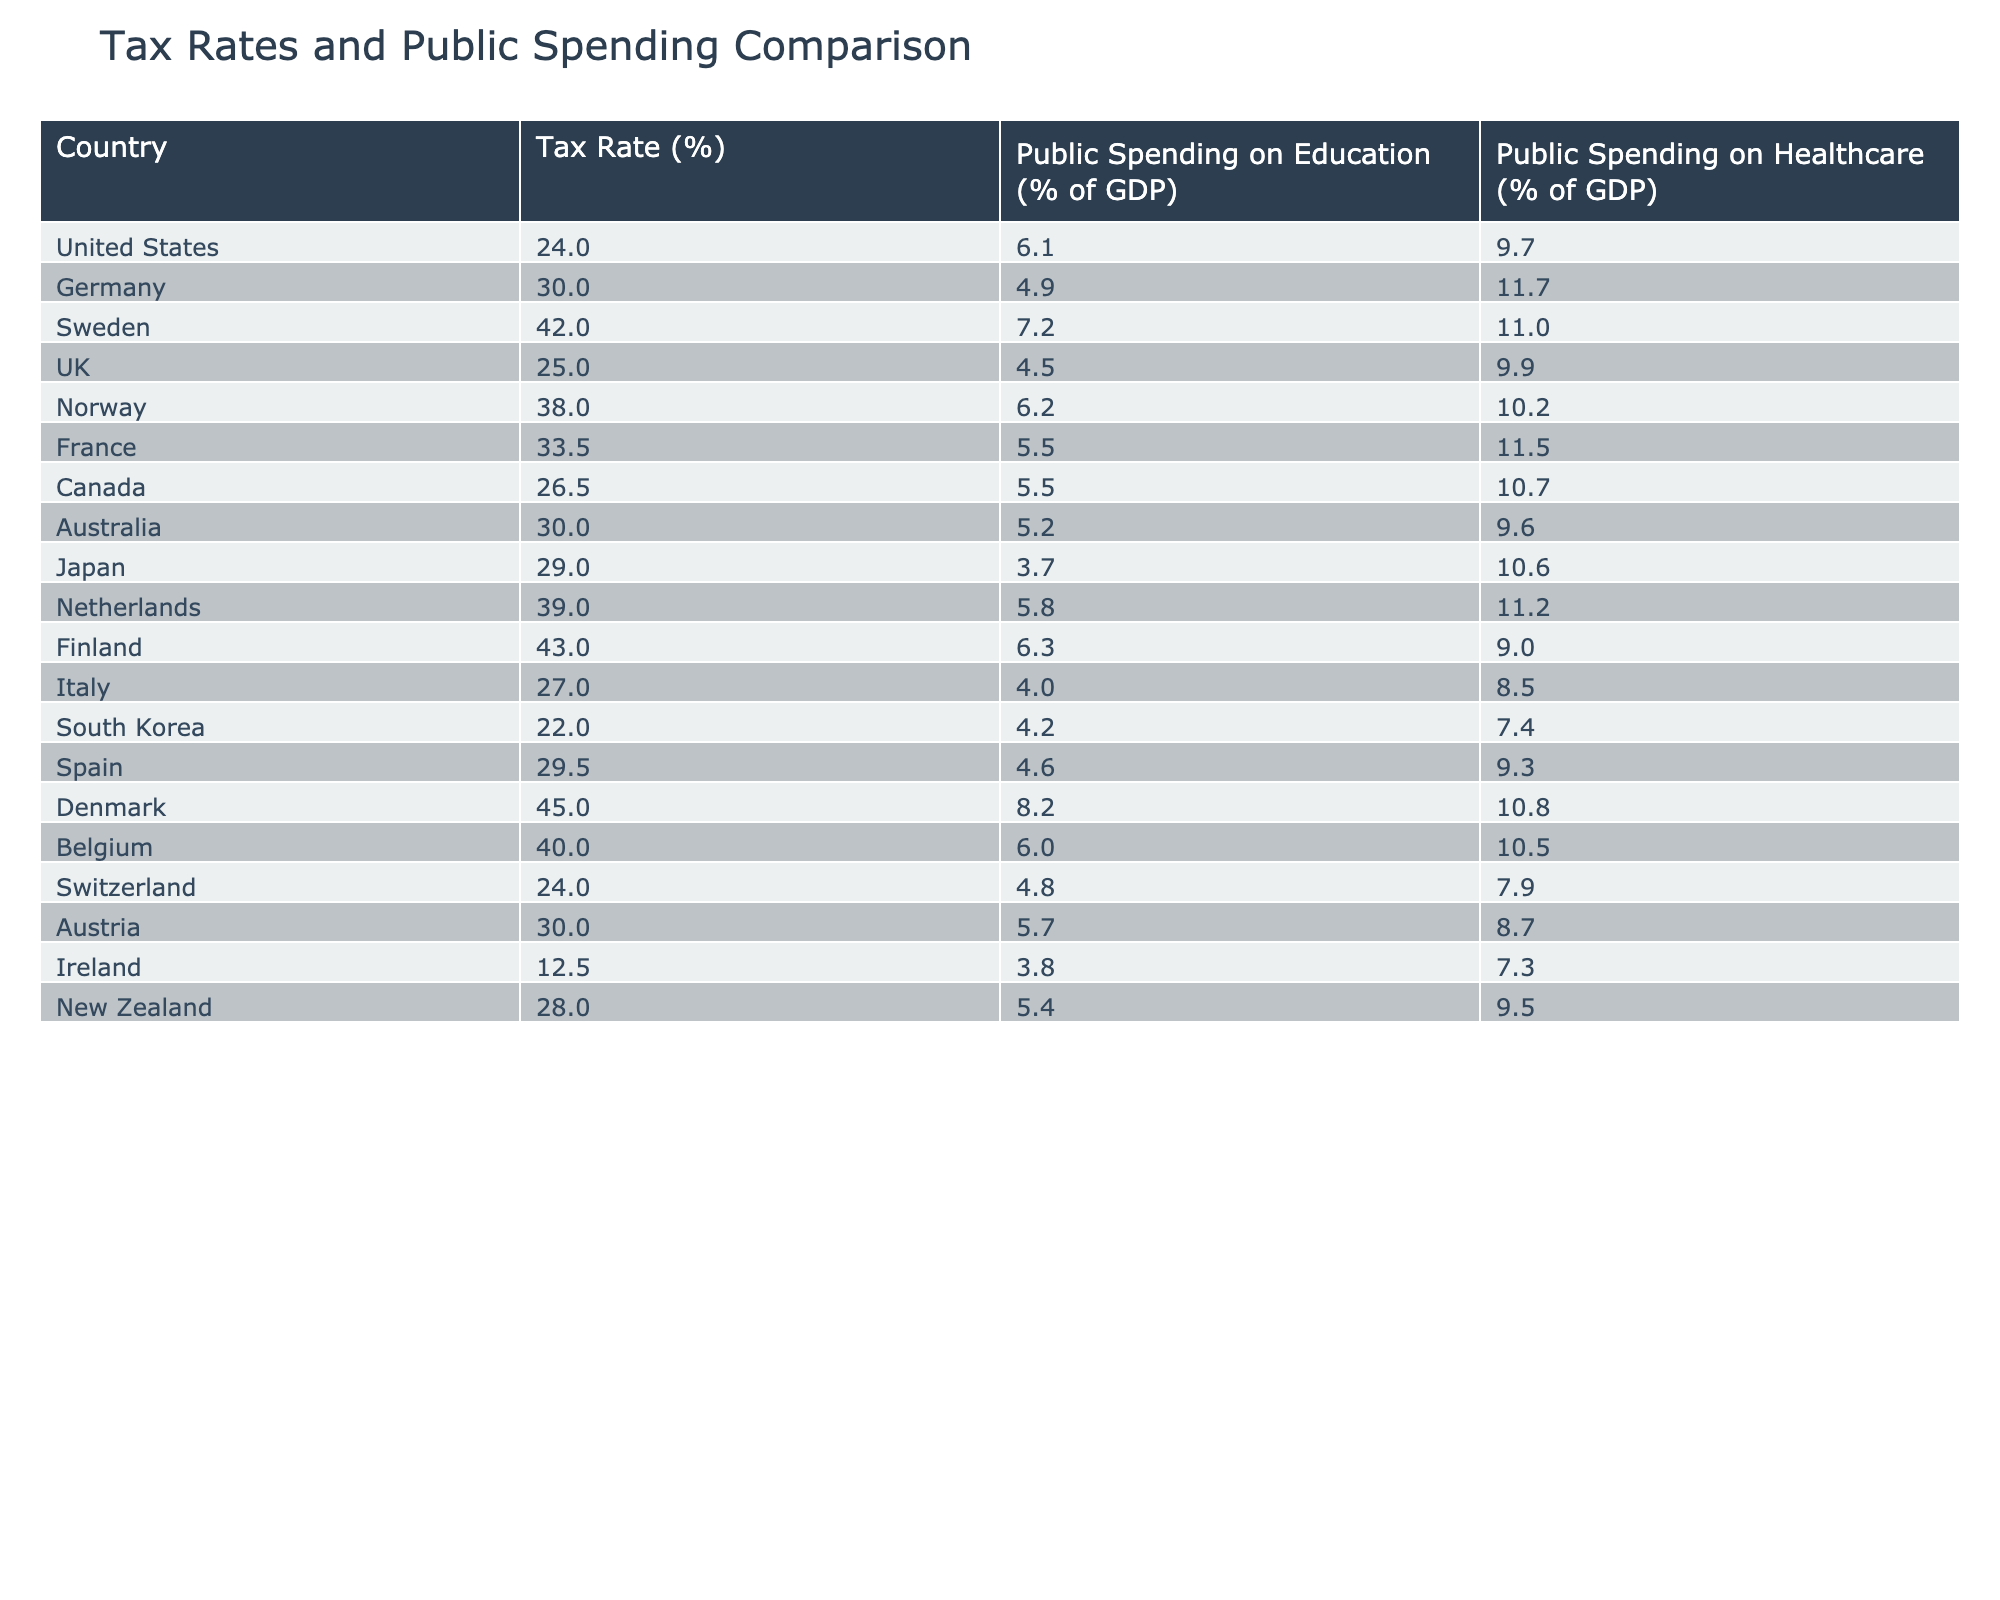What is the tax rate of Sweden? The table lists Sweden with a tax rate of 42.0%.
Answer: 42.0% Which country has the highest public spending on education? Denmark has the highest public spending on education at 8.2% of GDP.
Answer: Denmark What is the public spending on healthcare for Canada? According to the table, Canada spends 10.7% of its GDP on healthcare.
Answer: 10.7% Which country has the lowest tax rate? Ireland has the lowest tax rate at 12.5%.
Answer: 12.5% What is the average public spending on education across all countries in the table? The total spending on education is (6.1 + 4.9 + 7.2 + 4.5 + 6.2 + 5.5 + 5.5 + 5.2 + 3.7 + 5.8 + 6.3 + 4.0 + 4.2 + 4.6 + 8.2 + 6.0 + 4.8 + 5.7 + 3.8 + 5.4) = 90.0%. Dividing this by the number of countries (20) gives an average of 4.5%.
Answer: 4.5% Is public spending on education in Germany higher than in the UK? Germany spends 4.9% while the UK spends 4.5%, so it is higher.
Answer: Yes What is the difference between the public spending on healthcare in the United States and Japan? The United States spends 9.7% and Japan spends 10.6%, so the difference is 10.6% - 9.7% = 0.9%.
Answer: 0.9% Which country’s public spending on healthcare and education is below 5%? Both Italy and South Korea have public spending below 5% on education.
Answer: Italy and South Korea If you consider the relationship between tax rates and public spending on education, which country has the highest tax rate among those spending over 7% on education? Sweden at 42.0% tax rate spends 7.2% on education, which is the highest tax rate for spending over 7%.
Answer: Sweden What percentage of GDP does Denmark allocate to public spending on healthcare? Denmark allocates 10.8% of its GDP to public spending on healthcare.
Answer: 10.8% What is the correlation between the highest tax rate and the lowest public spending on education? Denmark has the highest tax rate of 45.0% but has the highest public spending on education at 8.2%.
Answer: Not applicable; Denmark is an outlier 